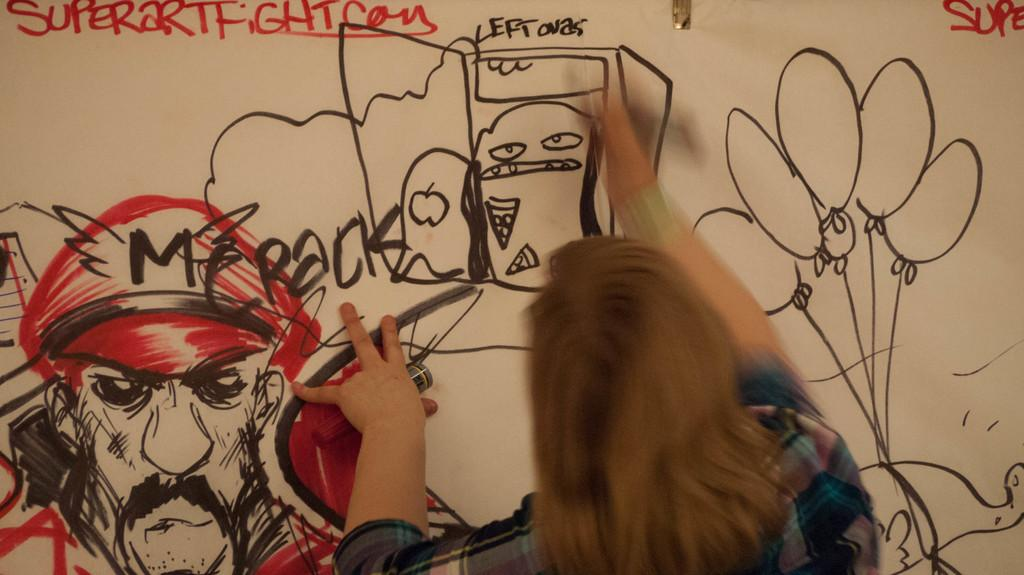What is the main subject of the image? There is a person in the image. What is the person holding in the image? The person is holding a marker. What is the person doing with the marker? The person is sketching on a wall. What type of bean is being harvested in the image? There is no bean or plantation present in the image; it features a person sketching on a wall with a marker. 